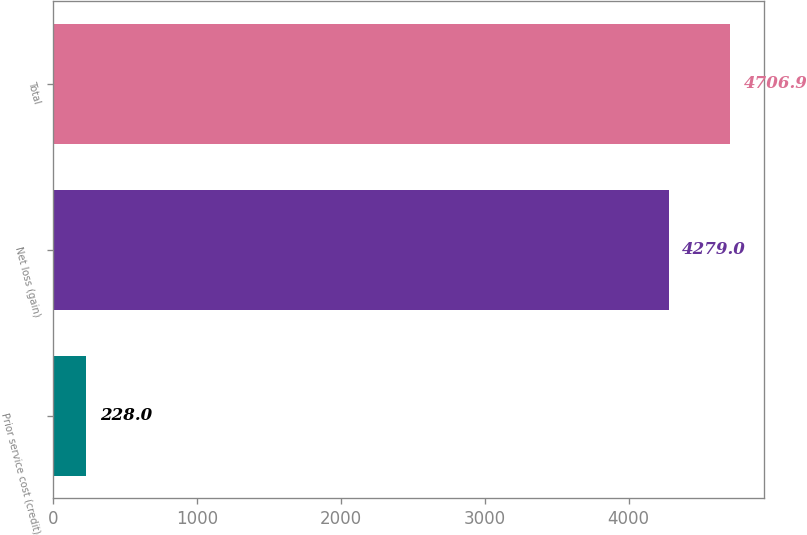Convert chart. <chart><loc_0><loc_0><loc_500><loc_500><bar_chart><fcel>Prior service cost (credit)<fcel>Net loss (gain)<fcel>Total<nl><fcel>228<fcel>4279<fcel>4706.9<nl></chart> 